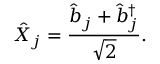Convert formula to latex. <formula><loc_0><loc_0><loc_500><loc_500>\hat { X } _ { j } = \frac { \hat { b } _ { j } + \hat { b } _ { j } ^ { \dagger } } { \sqrt { 2 } } .</formula> 